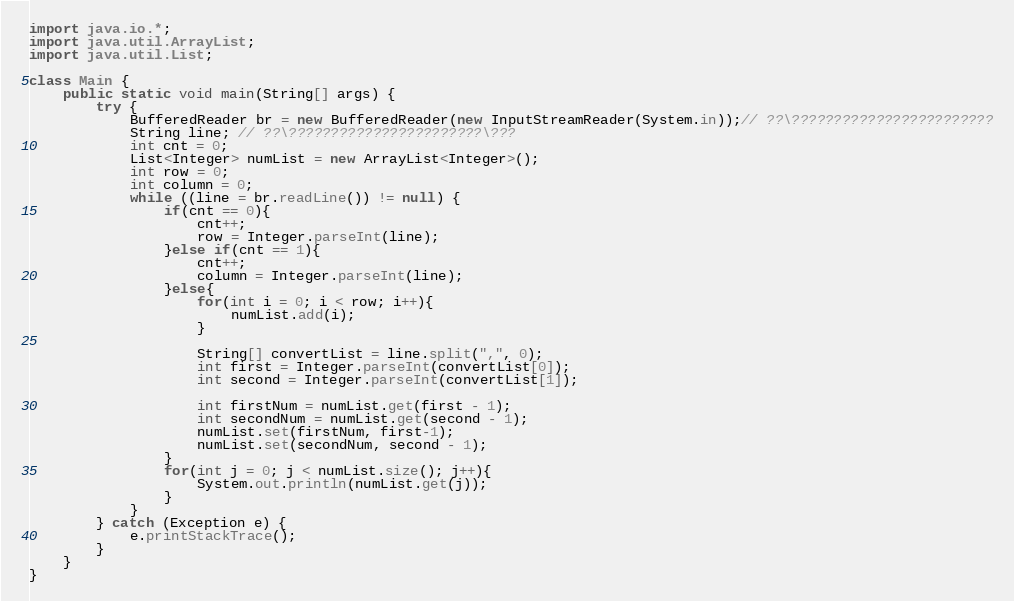Convert code to text. <code><loc_0><loc_0><loc_500><loc_500><_Java_>import java.io.*;
import java.util.ArrayList;
import java.util.List;

class Main {
    public static void main(String[] args) {
        try {
            BufferedReader br = new BufferedReader(new InputStreamReader(System.in));// ??\????????????????????????
            String line; // ??\???????????????????????\???
            int cnt = 0;
            List<Integer> numList = new ArrayList<Integer>();
            int row = 0;
            int column = 0;
            while ((line = br.readLine()) != null) {
            	if(cnt == 0){
            		cnt++;
            		row = Integer.parseInt(line);
            	}else if(cnt == 1){
            		cnt++;
            		column = Integer.parseInt(line);
            	}else{
            		for(int i = 0; i < row; i++){
            			numList.add(i);
            		}
            		
            		String[] convertList = line.split(",", 0);
            		int first = Integer.parseInt(convertList[0]);
            		int second = Integer.parseInt(convertList[1]);
            		
            		int firstNum = numList.get(first - 1);
            		int secondNum = numList.get(second - 1);
            		numList.set(firstNum, first-1);
            		numList.set(secondNum, second - 1);
            	}
            	for(int j = 0; j < numList.size(); j++){
            		System.out.println(numList.get(j));
            	}     	
            }
        } catch (Exception e) {
            e.printStackTrace();
        }
    }
}</code> 